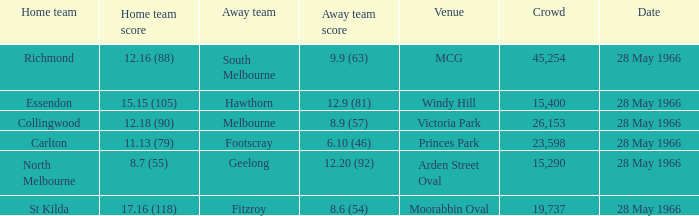Can you parse all the data within this table? {'header': ['Home team', 'Home team score', 'Away team', 'Away team score', 'Venue', 'Crowd', 'Date'], 'rows': [['Richmond', '12.16 (88)', 'South Melbourne', '9.9 (63)', 'MCG', '45,254', '28 May 1966'], ['Essendon', '15.15 (105)', 'Hawthorn', '12.9 (81)', 'Windy Hill', '15,400', '28 May 1966'], ['Collingwood', '12.18 (90)', 'Melbourne', '8.9 (57)', 'Victoria Park', '26,153', '28 May 1966'], ['Carlton', '11.13 (79)', 'Footscray', '6.10 (46)', 'Princes Park', '23,598', '28 May 1966'], ['North Melbourne', '8.7 (55)', 'Geelong', '12.20 (92)', 'Arden Street Oval', '15,290', '28 May 1966'], ['St Kilda', '17.16 (118)', 'Fitzroy', '8.6 (54)', 'Moorabbin Oval', '19,737', '28 May 1966']]} Which Crowd has a Home team of richmond? 45254.0. 